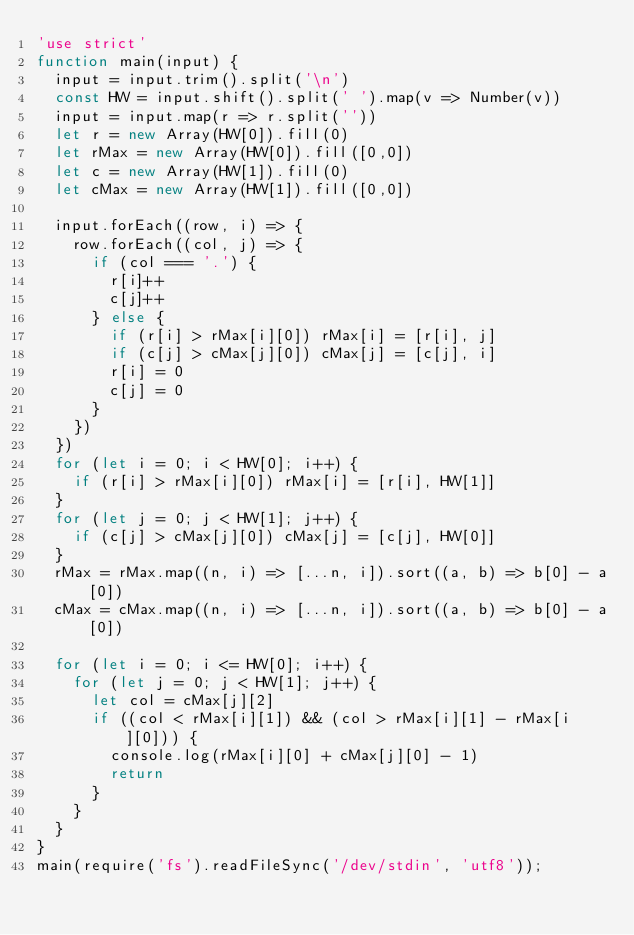Convert code to text. <code><loc_0><loc_0><loc_500><loc_500><_JavaScript_>'use strict'
function main(input) {
  input = input.trim().split('\n')
  const HW = input.shift().split(' ').map(v => Number(v))
  input = input.map(r => r.split(''))
  let r = new Array(HW[0]).fill(0)
  let rMax = new Array(HW[0]).fill([0,0])
  let c = new Array(HW[1]).fill(0)
  let cMax = new Array(HW[1]).fill([0,0])
  
  input.forEach((row, i) => {
    row.forEach((col, j) => {
      if (col === '.') {
        r[i]++
        c[j]++
      } else {
        if (r[i] > rMax[i][0]) rMax[i] = [r[i], j]
        if (c[j] > cMax[j][0]) cMax[j] = [c[j], i]
        r[i] = 0
        c[j] = 0
      }
    })
  })
  for (let i = 0; i < HW[0]; i++) {
    if (r[i] > rMax[i][0]) rMax[i] = [r[i], HW[1]]
  }
  for (let j = 0; j < HW[1]; j++) {
    if (c[j] > cMax[j][0]) cMax[j] = [c[j], HW[0]]
  }
  rMax = rMax.map((n, i) => [...n, i]).sort((a, b) => b[0] - a[0])
  cMax = cMax.map((n, i) => [...n, i]).sort((a, b) => b[0] - a[0])

  for (let i = 0; i <= HW[0]; i++) {
    for (let j = 0; j < HW[1]; j++) {
      let col = cMax[j][2]
      if ((col < rMax[i][1]) && (col > rMax[i][1] - rMax[i][0])) {
        console.log(rMax[i][0] + cMax[j][0] - 1)
        return
      }
    }
  }
}
main(require('fs').readFileSync('/dev/stdin', 'utf8'));
</code> 